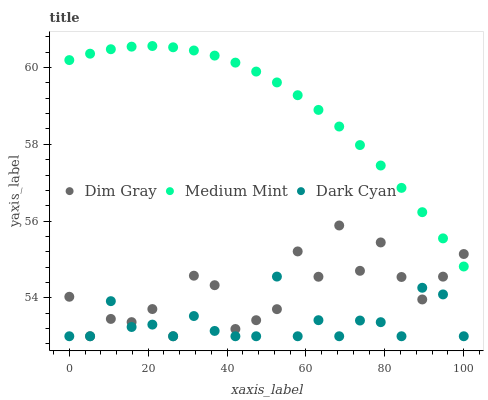Does Dark Cyan have the minimum area under the curve?
Answer yes or no. Yes. Does Medium Mint have the maximum area under the curve?
Answer yes or no. Yes. Does Dim Gray have the minimum area under the curve?
Answer yes or no. No. Does Dim Gray have the maximum area under the curve?
Answer yes or no. No. Is Medium Mint the smoothest?
Answer yes or no. Yes. Is Dim Gray the roughest?
Answer yes or no. Yes. Is Dark Cyan the smoothest?
Answer yes or no. No. Is Dark Cyan the roughest?
Answer yes or no. No. Does Dark Cyan have the lowest value?
Answer yes or no. Yes. Does Medium Mint have the highest value?
Answer yes or no. Yes. Does Dim Gray have the highest value?
Answer yes or no. No. Is Dark Cyan less than Medium Mint?
Answer yes or no. Yes. Is Medium Mint greater than Dark Cyan?
Answer yes or no. Yes. Does Dim Gray intersect Medium Mint?
Answer yes or no. Yes. Is Dim Gray less than Medium Mint?
Answer yes or no. No. Is Dim Gray greater than Medium Mint?
Answer yes or no. No. Does Dark Cyan intersect Medium Mint?
Answer yes or no. No. 